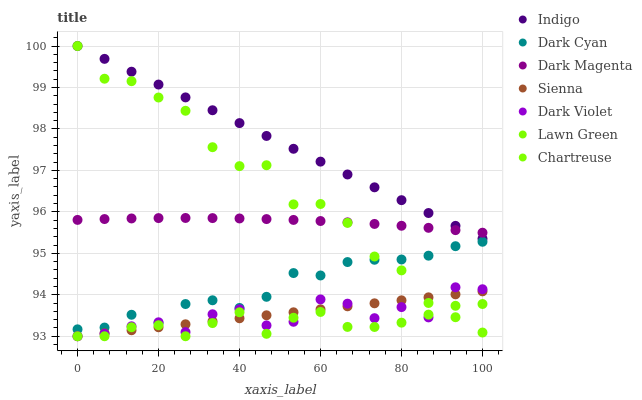Does Lawn Green have the minimum area under the curve?
Answer yes or no. Yes. Does Indigo have the maximum area under the curve?
Answer yes or no. Yes. Does Dark Magenta have the minimum area under the curve?
Answer yes or no. No. Does Dark Magenta have the maximum area under the curve?
Answer yes or no. No. Is Sienna the smoothest?
Answer yes or no. Yes. Is Chartreuse the roughest?
Answer yes or no. Yes. Is Indigo the smoothest?
Answer yes or no. No. Is Indigo the roughest?
Answer yes or no. No. Does Lawn Green have the lowest value?
Answer yes or no. Yes. Does Indigo have the lowest value?
Answer yes or no. No. Does Chartreuse have the highest value?
Answer yes or no. Yes. Does Dark Magenta have the highest value?
Answer yes or no. No. Is Dark Cyan less than Dark Magenta?
Answer yes or no. Yes. Is Indigo greater than Lawn Green?
Answer yes or no. Yes. Does Indigo intersect Chartreuse?
Answer yes or no. Yes. Is Indigo less than Chartreuse?
Answer yes or no. No. Is Indigo greater than Chartreuse?
Answer yes or no. No. Does Dark Cyan intersect Dark Magenta?
Answer yes or no. No. 